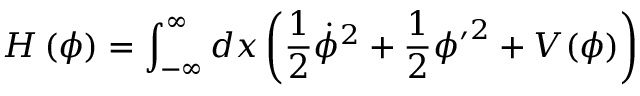<formula> <loc_0><loc_0><loc_500><loc_500>H \left ( \phi \right ) = \int _ { - \infty } ^ { \infty } d x \left ( \frac { 1 } { 2 } \dot { \phi } ^ { 2 } + \frac { 1 } { 2 } { \phi ^ { \prime } } ^ { 2 } + V ( \phi ) \right )</formula> 